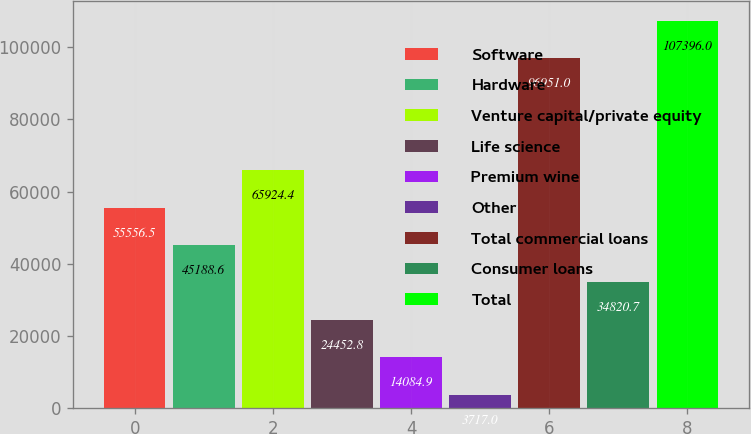<chart> <loc_0><loc_0><loc_500><loc_500><bar_chart><fcel>Software<fcel>Hardware<fcel>Venture capital/private equity<fcel>Life science<fcel>Premium wine<fcel>Other<fcel>Total commercial loans<fcel>Consumer loans<fcel>Total<nl><fcel>55556.5<fcel>45188.6<fcel>65924.4<fcel>24452.8<fcel>14084.9<fcel>3717<fcel>96951<fcel>34820.7<fcel>107396<nl></chart> 